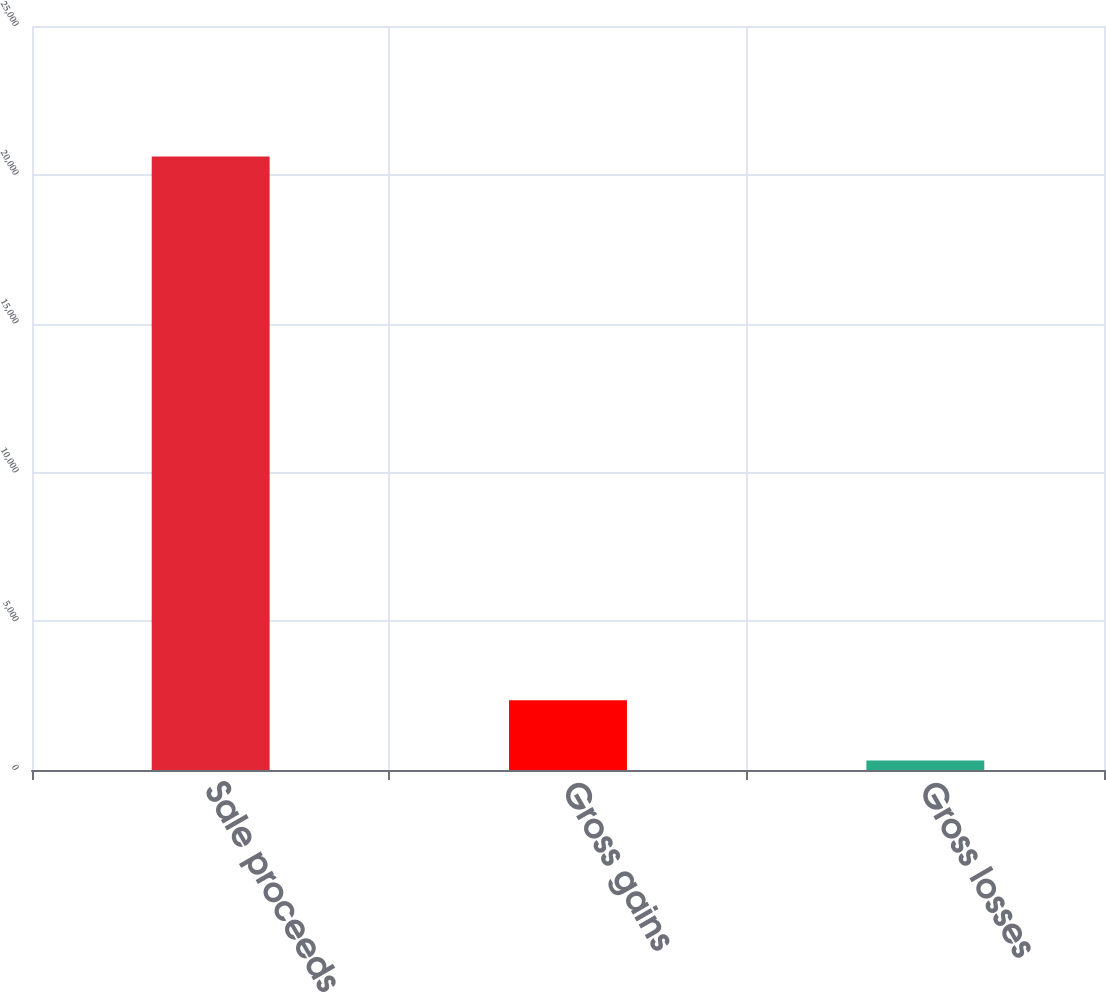Convert chart to OTSL. <chart><loc_0><loc_0><loc_500><loc_500><bar_chart><fcel>Sale proceeds<fcel>Gross gains<fcel>Gross losses<nl><fcel>20615<fcel>2346.8<fcel>317<nl></chart> 